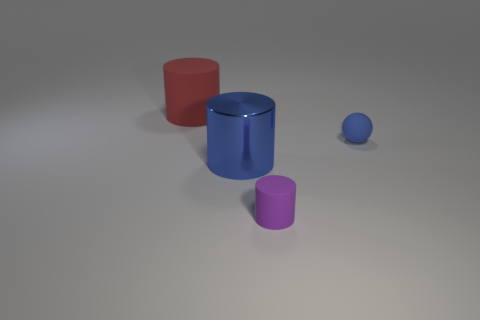Add 2 red cylinders. How many objects exist? 6 Subtract all cylinders. How many objects are left? 1 Subtract 1 blue balls. How many objects are left? 3 Subtract all tiny blue things. Subtract all small blue rubber spheres. How many objects are left? 2 Add 2 big shiny things. How many big shiny things are left? 3 Add 4 large green shiny balls. How many large green shiny balls exist? 4 